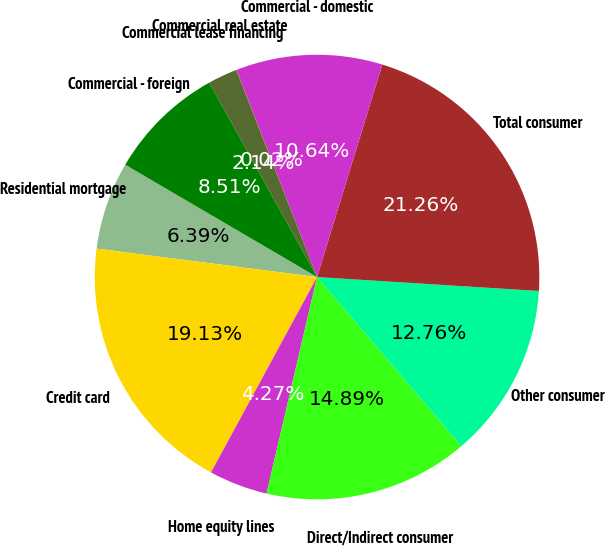Convert chart to OTSL. <chart><loc_0><loc_0><loc_500><loc_500><pie_chart><fcel>Residential mortgage<fcel>Credit card<fcel>Home equity lines<fcel>Direct/Indirect consumer<fcel>Other consumer<fcel>Total consumer<fcel>Commercial - domestic<fcel>Commercial real estate<fcel>Commercial lease financing<fcel>Commercial - foreign<nl><fcel>6.39%<fcel>19.13%<fcel>4.27%<fcel>14.89%<fcel>12.76%<fcel>21.26%<fcel>10.64%<fcel>0.02%<fcel>2.14%<fcel>8.51%<nl></chart> 